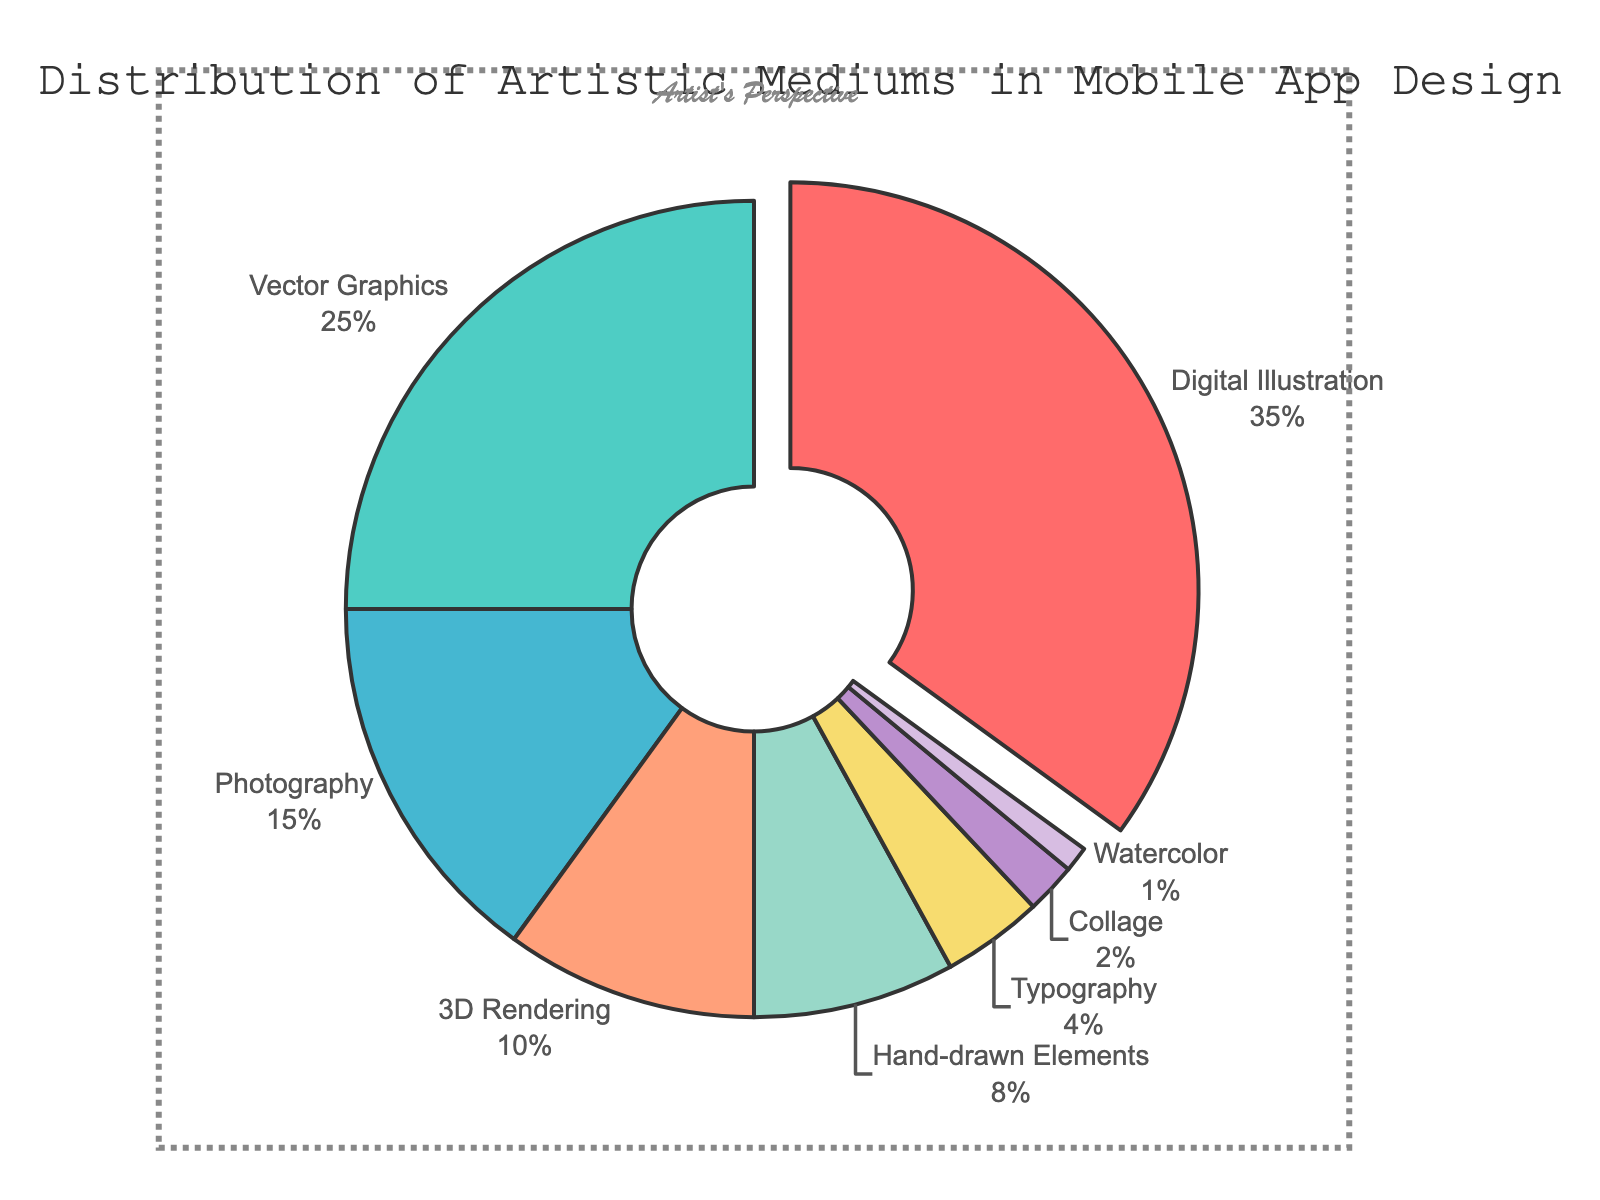What's the largest segment in the pie chart? The chart shows a 'pull' effect on the largest segment, which is labeled 'Digital Illustration'. This segment also has the highest percentage marked on it, indicating it's the largest.
Answer: Digital Illustration What's the combined percentage of Vector Graphics and 3D Rendering? The percentage for Vector Graphics is 25%, and for 3D Rendering, it's 10%. Adding these two percentages: 25 + 10 = 35%.
Answer: 35% Which medium represents 8% of the overall distribution? Upon examining each segment and their respective percentages, 'Hand-drawn Elements' is identified as the medium representing 8% of the distribution.
Answer: Hand-drawn Elements Which medium uses the purple color in the pie chart? By visually identifying the purple color segment, it corresponds to 'Hand-drawn Elements' in the legend and the chart.
Answer: Hand-drawn Elements Out of Typography and Collage, which has a higher percentage? Typography is labeled with 4%, and Collage has 2%. Comparing these values, Typography has a higher percentage than Collage.
Answer: Typography How much larger is the percentage of Digital Illustration compared to Photography? Digital Illustration is 35%, and Photography is 15%. The difference is 35 - 15 = 20%.
Answer: 20% Which medium has the smallest representation, and what is its percentage? By inspecting the segments with their percentages, 'Watercolor' is the smallest with 1%.
Answer: Watercolor What is the combined percentage of all mediums except Digital Illustration? Summing the percentages of all other mediums: 25 (Vector Graphics) + 15 (Photography) + 10 (3D Rendering) + 8 (Hand-drawn Elements) + 4 (Typography) + 2 (Collage) + 1 (Watercolor) = 65%.
Answer: 65% Is the percentage of 3D Rendering greater than the combined percentage of Typography and Watercolor? 3D Rendering has 10%. Typography (4%) + Watercolor (1%) equals 5%. So, 10% is greater than 5%.
Answer: Yes 